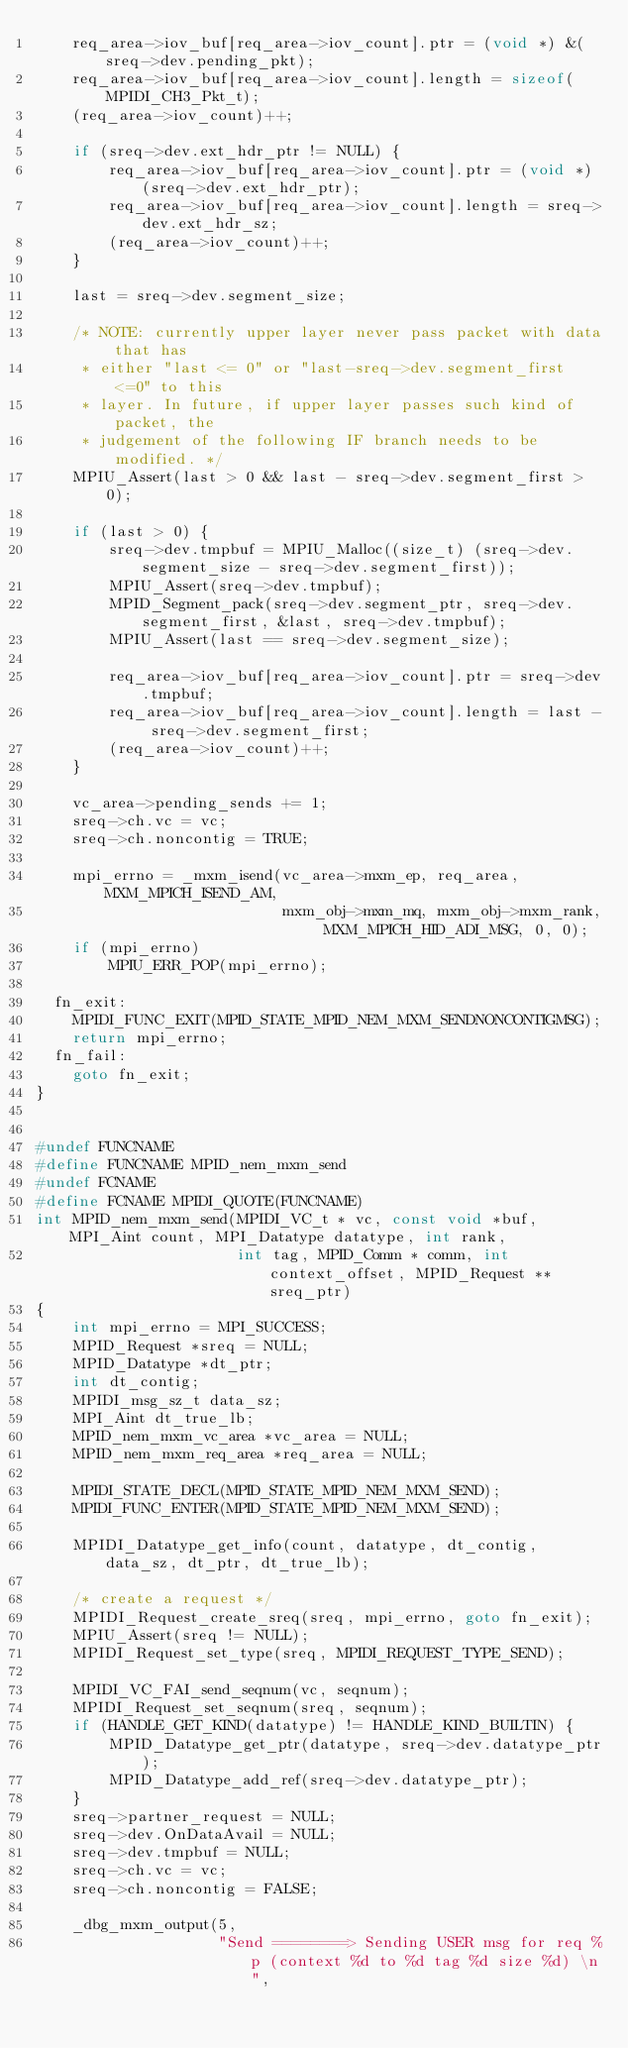Convert code to text. <code><loc_0><loc_0><loc_500><loc_500><_C_>    req_area->iov_buf[req_area->iov_count].ptr = (void *) &(sreq->dev.pending_pkt);
    req_area->iov_buf[req_area->iov_count].length = sizeof(MPIDI_CH3_Pkt_t);
    (req_area->iov_count)++;

    if (sreq->dev.ext_hdr_ptr != NULL) {
        req_area->iov_buf[req_area->iov_count].ptr = (void *) (sreq->dev.ext_hdr_ptr);
        req_area->iov_buf[req_area->iov_count].length = sreq->dev.ext_hdr_sz;
        (req_area->iov_count)++;
    }

    last = sreq->dev.segment_size;

    /* NOTE: currently upper layer never pass packet with data that has
     * either "last <= 0" or "last-sreq->dev.segment_first <=0" to this
     * layer. In future, if upper layer passes such kind of packet, the
     * judgement of the following IF branch needs to be modified. */
    MPIU_Assert(last > 0 && last - sreq->dev.segment_first > 0);

    if (last > 0) {
        sreq->dev.tmpbuf = MPIU_Malloc((size_t) (sreq->dev.segment_size - sreq->dev.segment_first));
        MPIU_Assert(sreq->dev.tmpbuf);
        MPID_Segment_pack(sreq->dev.segment_ptr, sreq->dev.segment_first, &last, sreq->dev.tmpbuf);
        MPIU_Assert(last == sreq->dev.segment_size);

        req_area->iov_buf[req_area->iov_count].ptr = sreq->dev.tmpbuf;
        req_area->iov_buf[req_area->iov_count].length = last - sreq->dev.segment_first;
        (req_area->iov_count)++;
    }

    vc_area->pending_sends += 1;
    sreq->ch.vc = vc;
    sreq->ch.noncontig = TRUE;

    mpi_errno = _mxm_isend(vc_area->mxm_ep, req_area, MXM_MPICH_ISEND_AM,
                           mxm_obj->mxm_mq, mxm_obj->mxm_rank, MXM_MPICH_HID_ADI_MSG, 0, 0);
    if (mpi_errno)
        MPIU_ERR_POP(mpi_errno);

  fn_exit:
    MPIDI_FUNC_EXIT(MPID_STATE_MPID_NEM_MXM_SENDNONCONTIGMSG);
    return mpi_errno;
  fn_fail:
    goto fn_exit;
}


#undef FUNCNAME
#define FUNCNAME MPID_nem_mxm_send
#undef FCNAME
#define FCNAME MPIDI_QUOTE(FUNCNAME)
int MPID_nem_mxm_send(MPIDI_VC_t * vc, const void *buf, MPI_Aint count, MPI_Datatype datatype, int rank,
                      int tag, MPID_Comm * comm, int context_offset, MPID_Request ** sreq_ptr)
{
    int mpi_errno = MPI_SUCCESS;
    MPID_Request *sreq = NULL;
    MPID_Datatype *dt_ptr;
    int dt_contig;
    MPIDI_msg_sz_t data_sz;
    MPI_Aint dt_true_lb;
    MPID_nem_mxm_vc_area *vc_area = NULL;
    MPID_nem_mxm_req_area *req_area = NULL;

    MPIDI_STATE_DECL(MPID_STATE_MPID_NEM_MXM_SEND);
    MPIDI_FUNC_ENTER(MPID_STATE_MPID_NEM_MXM_SEND);

    MPIDI_Datatype_get_info(count, datatype, dt_contig, data_sz, dt_ptr, dt_true_lb);

    /* create a request */
    MPIDI_Request_create_sreq(sreq, mpi_errno, goto fn_exit);
    MPIU_Assert(sreq != NULL);
    MPIDI_Request_set_type(sreq, MPIDI_REQUEST_TYPE_SEND);

    MPIDI_VC_FAI_send_seqnum(vc, seqnum);
    MPIDI_Request_set_seqnum(sreq, seqnum);
    if (HANDLE_GET_KIND(datatype) != HANDLE_KIND_BUILTIN) {
        MPID_Datatype_get_ptr(datatype, sreq->dev.datatype_ptr);
        MPID_Datatype_add_ref(sreq->dev.datatype_ptr);
    }
    sreq->partner_request = NULL;
    sreq->dev.OnDataAvail = NULL;
    sreq->dev.tmpbuf = NULL;
    sreq->ch.vc = vc;
    sreq->ch.noncontig = FALSE;

    _dbg_mxm_output(5,
                    "Send ========> Sending USER msg for req %p (context %d to %d tag %d size %d) \n",</code> 